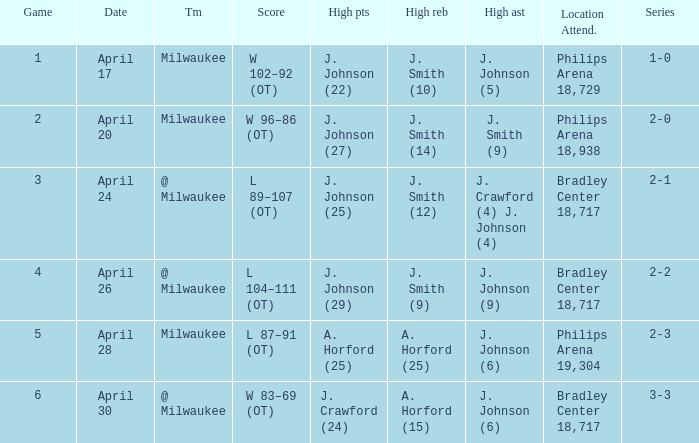What was the score in game 6? W 83–69 (OT). 